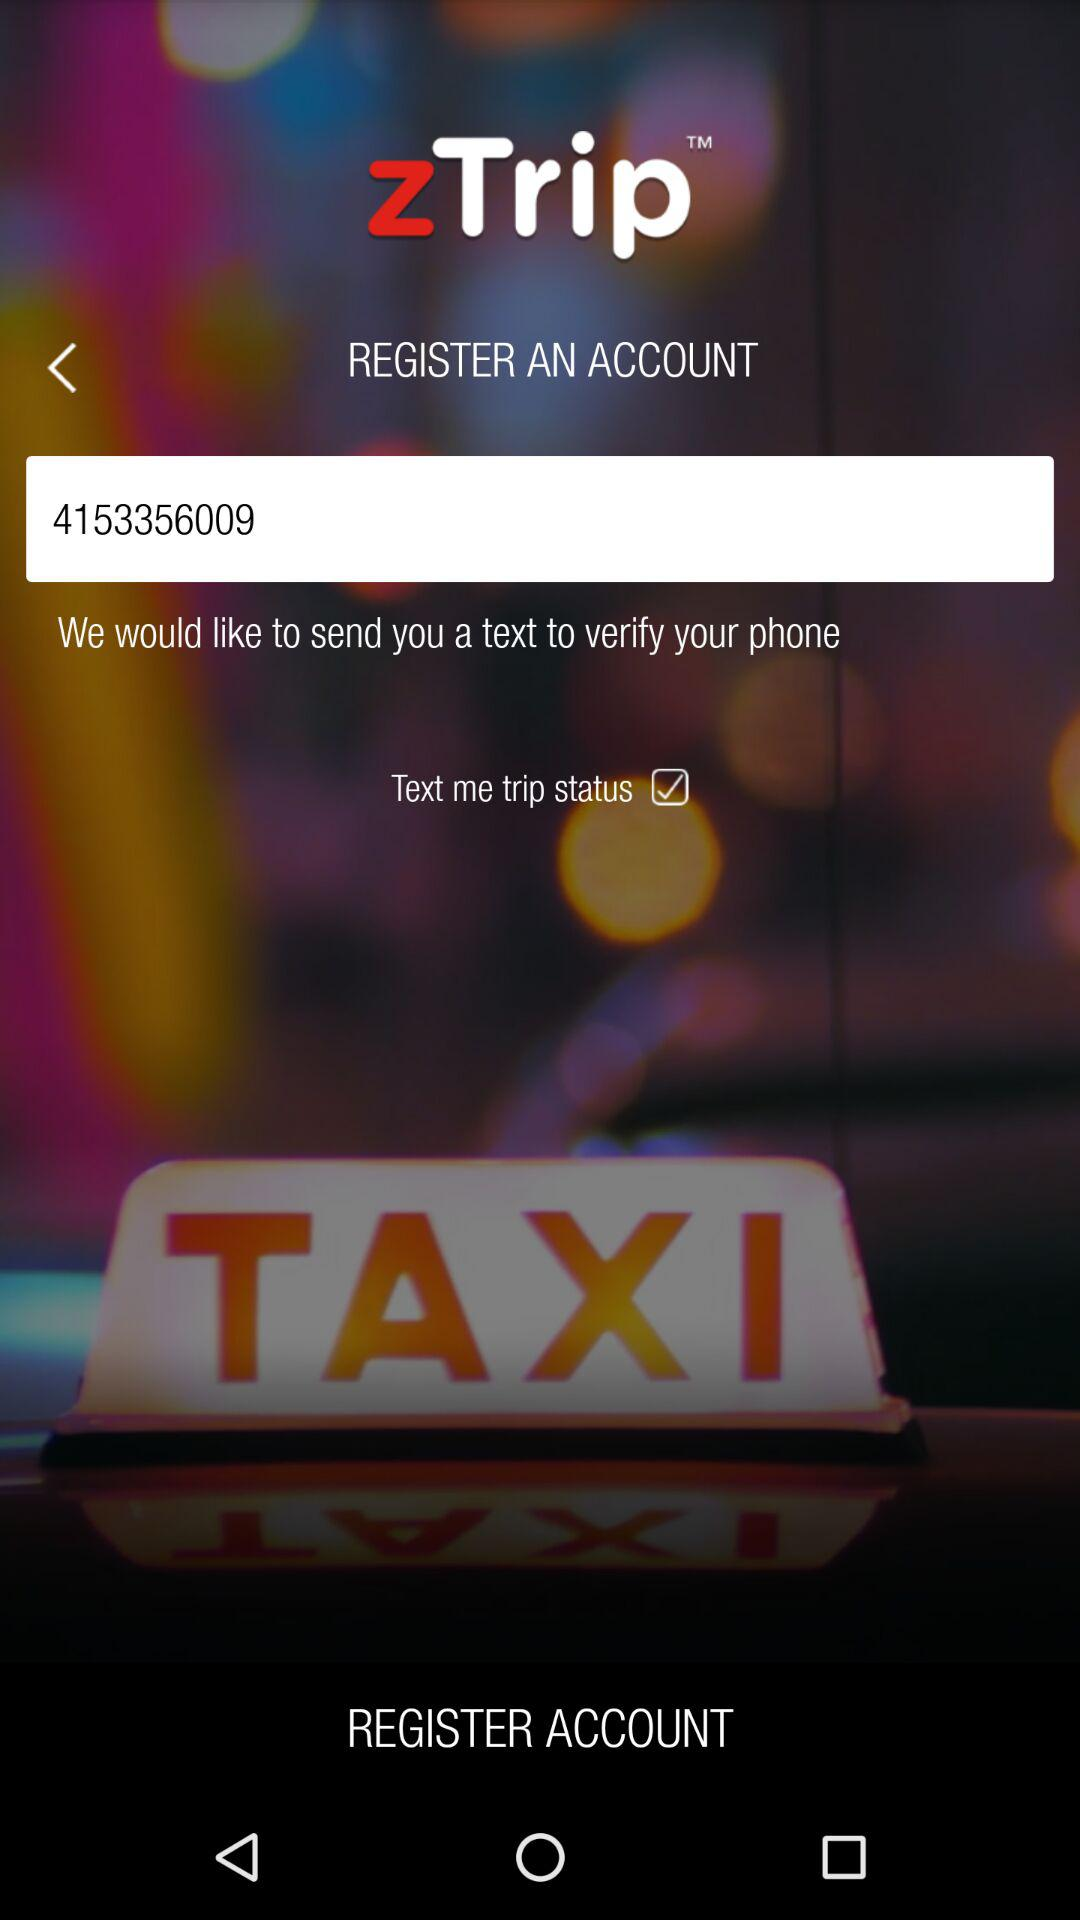What is the phone number? The phone number is 4153356009. 